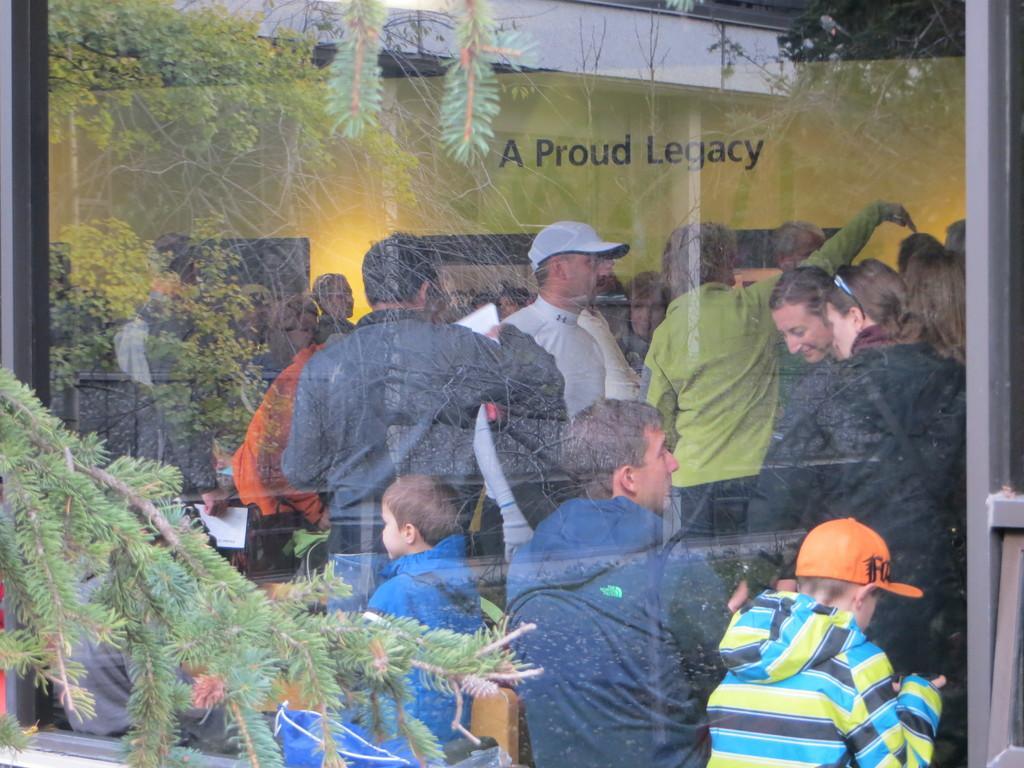Could you give a brief overview of what you see in this image? On the left side there is a branch of a tree. There is a glass wall. Through that we can see many people. Some are wearing caps. In the back there is a wall with something written on it. 